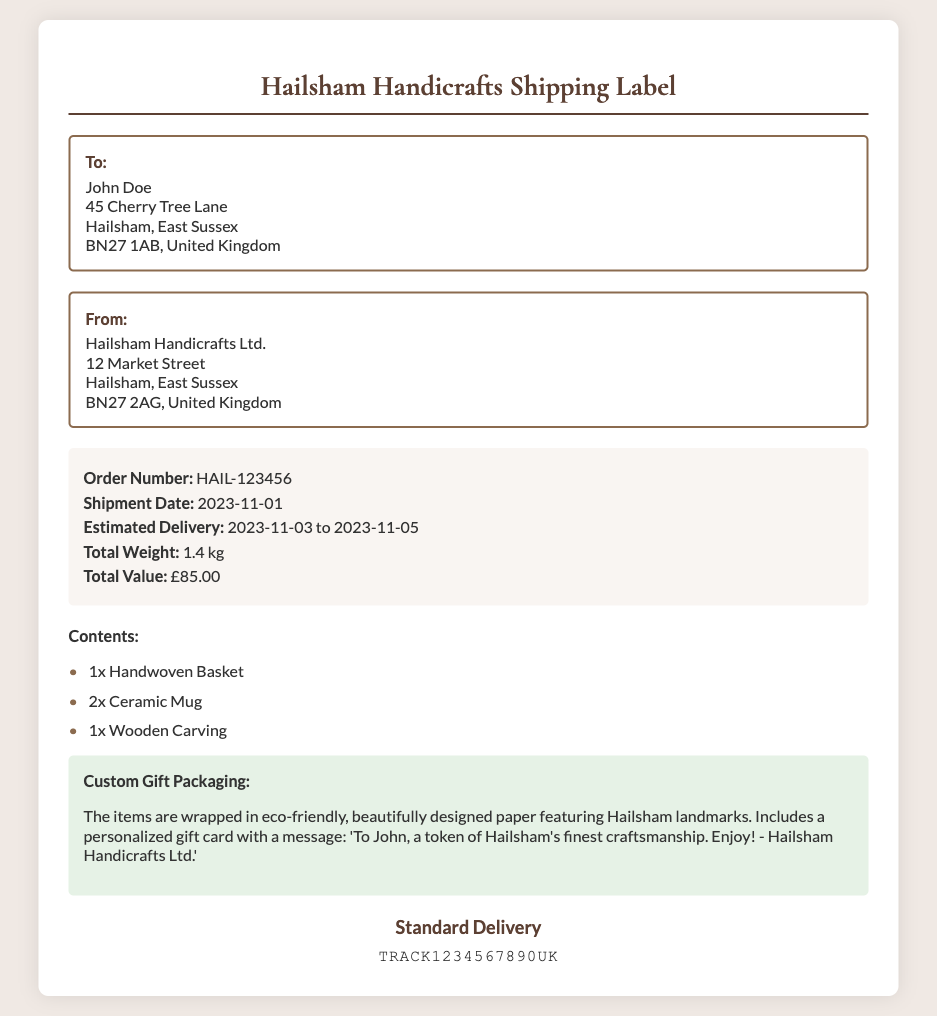what is the order number? The order number is listed in the order details section of the document.
Answer: HAIL-123456 who is the recipient of the package? The name of the recipient is shown in the "To:" section of the document.
Answer: John Doe what is the estimated delivery date? The estimated delivery date range is provided in the order details section.
Answer: 2023-11-03 to 2023-11-05 how much does the shipment weigh? The weight of the shipment is indicated in the order details section.
Answer: 1.4 kg what type of delivery is being used? The shipping method is stated at the bottom of the document.
Answer: Standard Delivery what is the total value of the order? The total value can be found in the order details section of the document.
Answer: £85.00 what items are included in the shipment? The contents of the shipment are listed in the items list section.
Answer: 1x Handwoven Basket, 2x Ceramic Mug, 1x Wooden Carving what customization is included for gift packaging? The details of the gift packaging are described in the gift packaging section of the document.
Answer: Eco-friendly paper, personalized gift card what is the tracking number provided? The tracking number is displayed in the tracking section of the document.
Answer: TRACK1234567890UK 